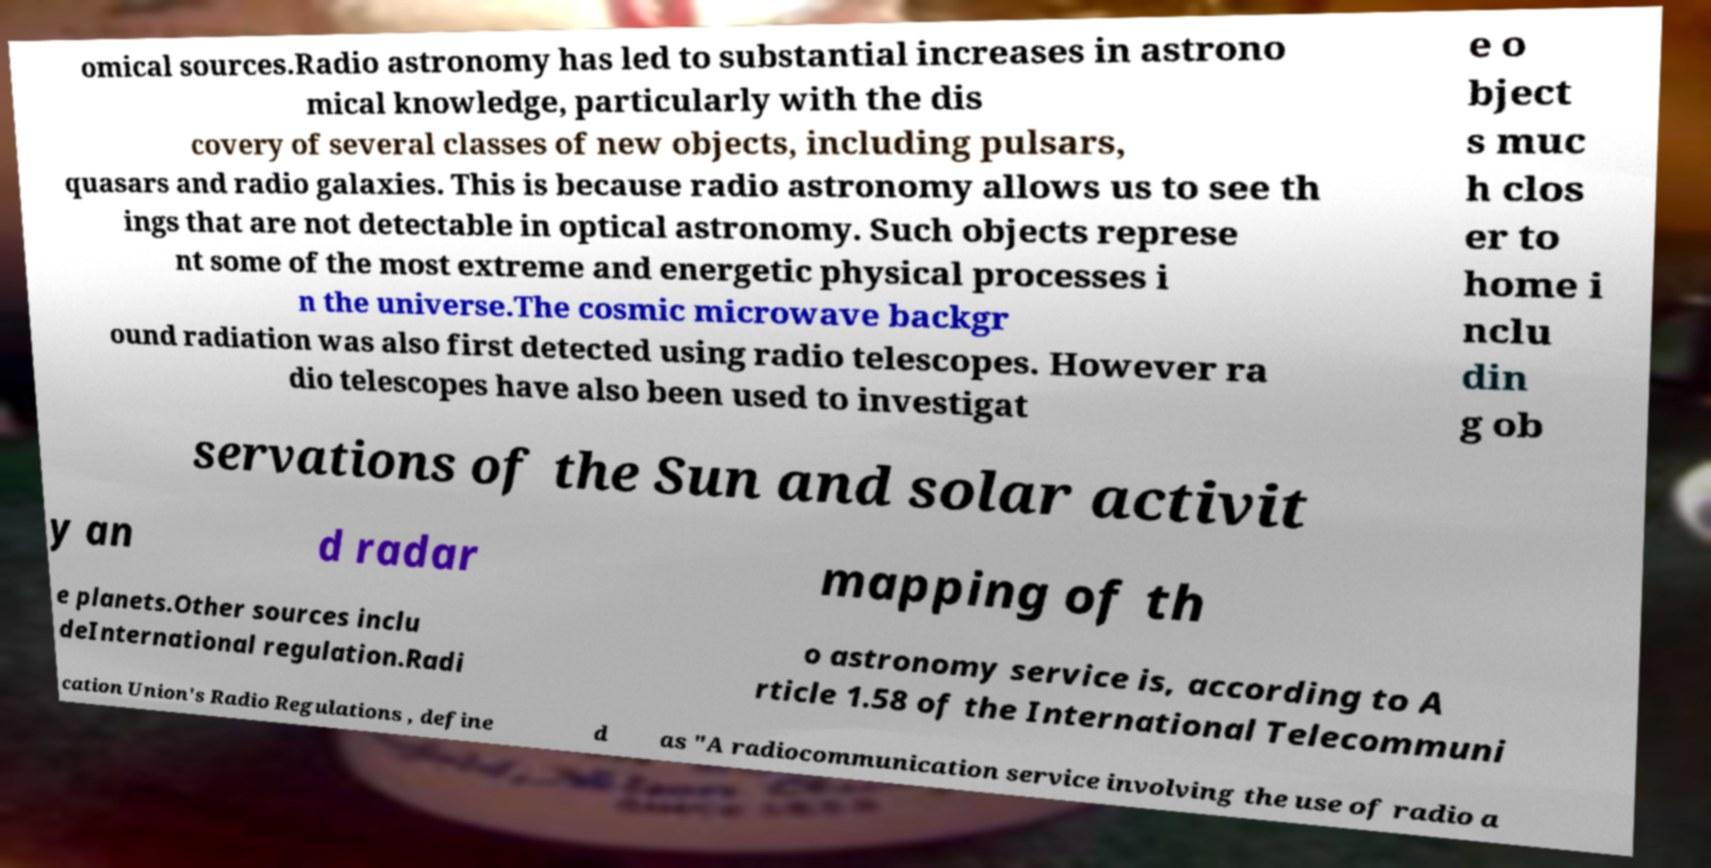What messages or text are displayed in this image? I need them in a readable, typed format. omical sources.Radio astronomy has led to substantial increases in astrono mical knowledge, particularly with the dis covery of several classes of new objects, including pulsars, quasars and radio galaxies. This is because radio astronomy allows us to see th ings that are not detectable in optical astronomy. Such objects represe nt some of the most extreme and energetic physical processes i n the universe.The cosmic microwave backgr ound radiation was also first detected using radio telescopes. However ra dio telescopes have also been used to investigat e o bject s muc h clos er to home i nclu din g ob servations of the Sun and solar activit y an d radar mapping of th e planets.Other sources inclu deInternational regulation.Radi o astronomy service is, according to A rticle 1.58 of the International Telecommuni cation Union's Radio Regulations , define d as "A radiocommunication service involving the use of radio a 